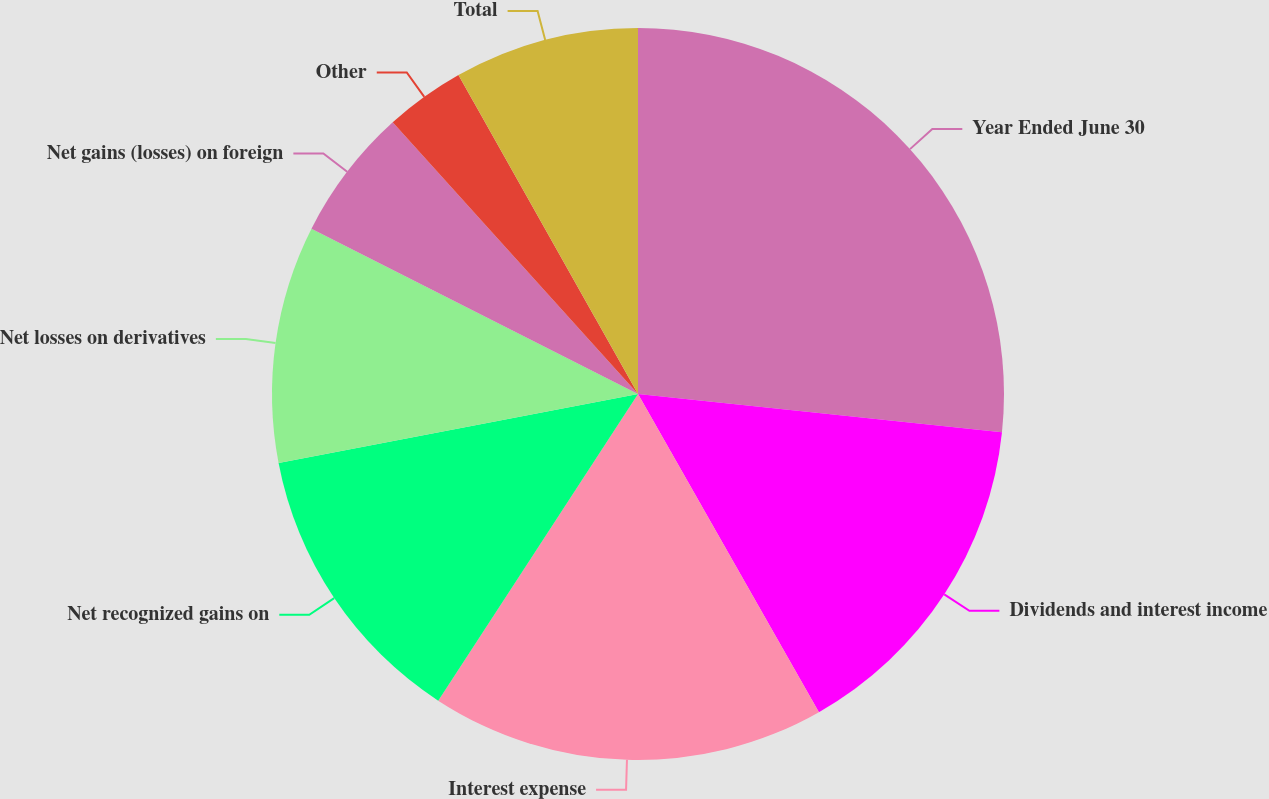<chart> <loc_0><loc_0><loc_500><loc_500><pie_chart><fcel>Year Ended June 30<fcel>Dividends and interest income<fcel>Interest expense<fcel>Net recognized gains on<fcel>Net losses on derivatives<fcel>Net gains (losses) on foreign<fcel>Other<fcel>Total<nl><fcel>26.67%<fcel>15.1%<fcel>17.42%<fcel>12.79%<fcel>10.48%<fcel>5.85%<fcel>3.53%<fcel>8.16%<nl></chart> 